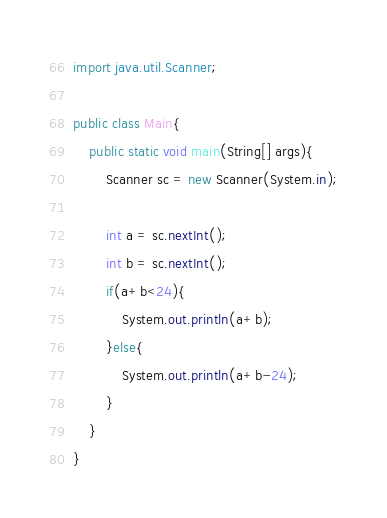Convert code to text. <code><loc_0><loc_0><loc_500><loc_500><_Java_>import java.util.Scanner;

public class Main{
    public static void main(String[] args){
        Scanner sc = new Scanner(System.in);
        
        int a = sc.nextInt();
        int b = sc.nextInt();
        if(a+b<24){
            System.out.println(a+b);
        }else{
            System.out.println(a+b-24);
        }
    }
}</code> 